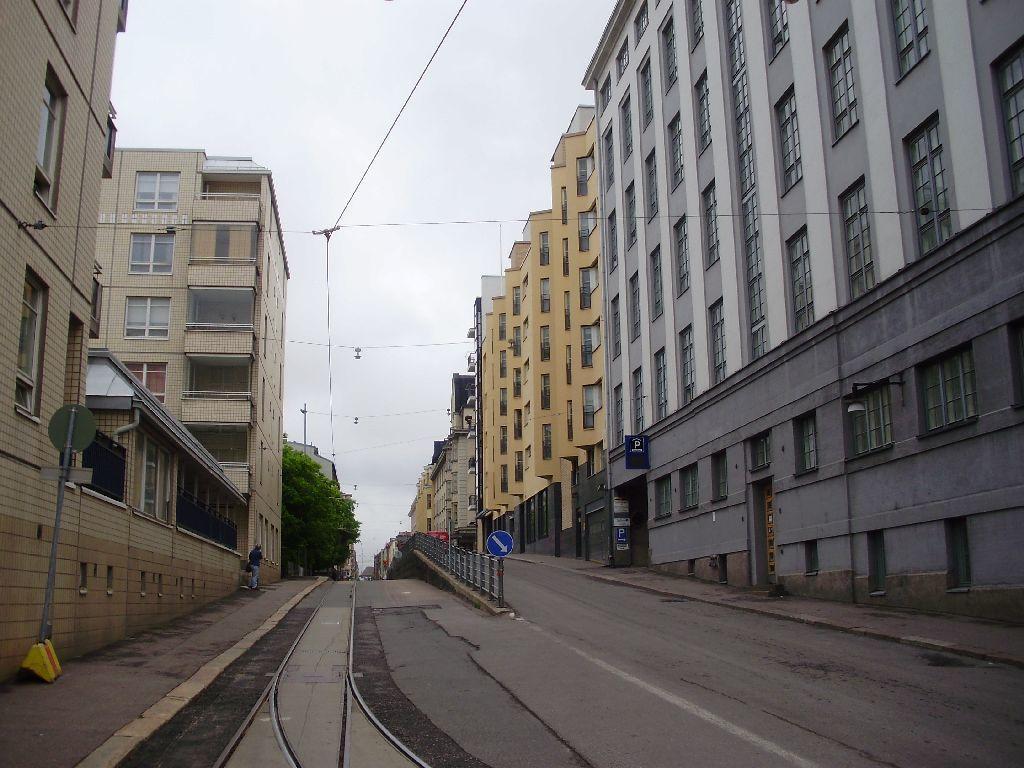Describe this image in one or two sentences. In this image, we can see buildings, walls, windows, sign boards, poles, banners, sticker, railing and roads. Background we can see trees and sky. Here a person is standing on the walkway. 